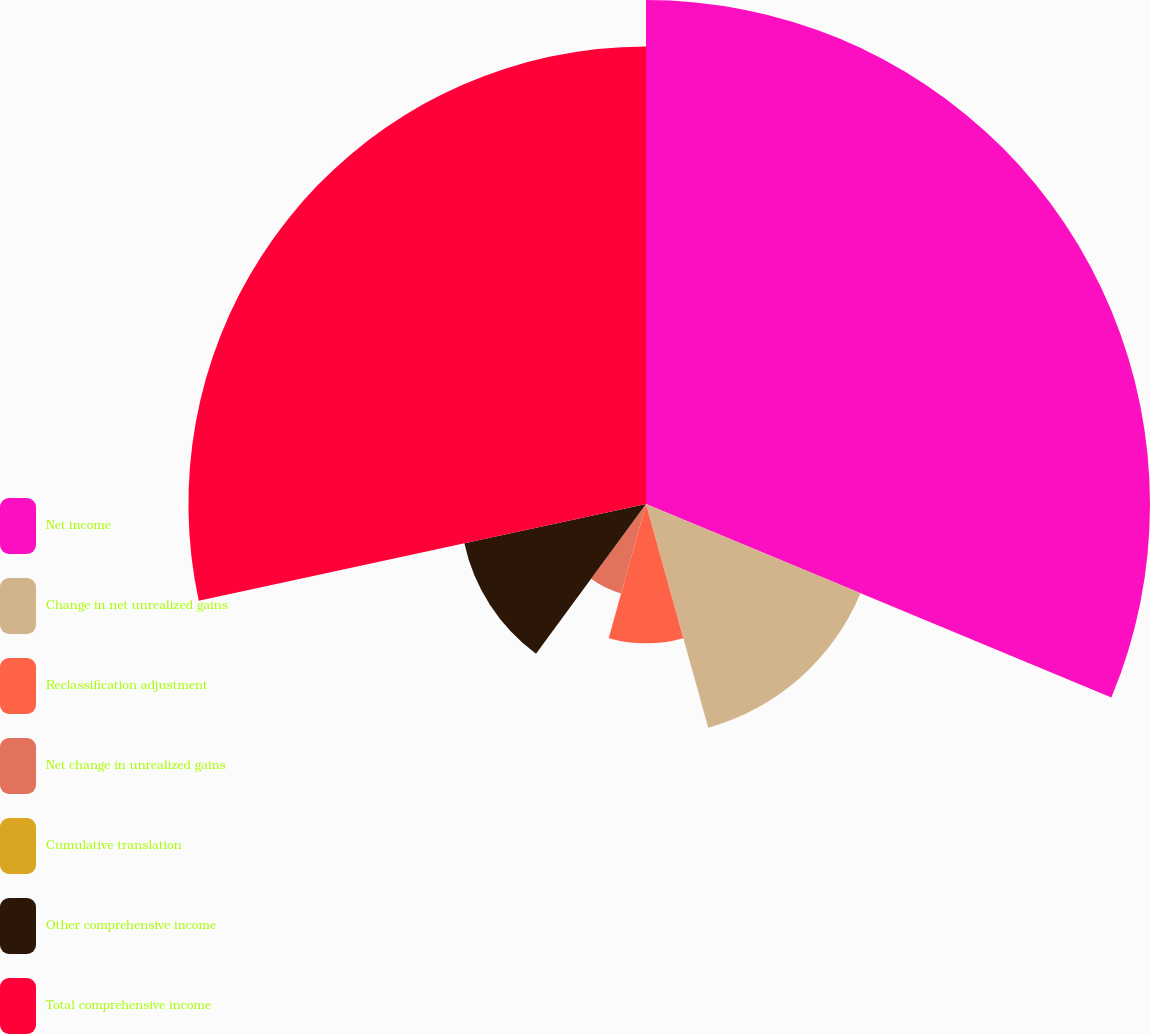Convert chart. <chart><loc_0><loc_0><loc_500><loc_500><pie_chart><fcel>Net income<fcel>Change in net unrealized gains<fcel>Reclassification adjustment<fcel>Net change in unrealized gains<fcel>Cumulative translation<fcel>Other comprehensive income<fcel>Total comprehensive income<nl><fcel>31.27%<fcel>14.41%<fcel>8.64%<fcel>5.76%<fcel>0.0%<fcel>11.53%<fcel>28.39%<nl></chart> 